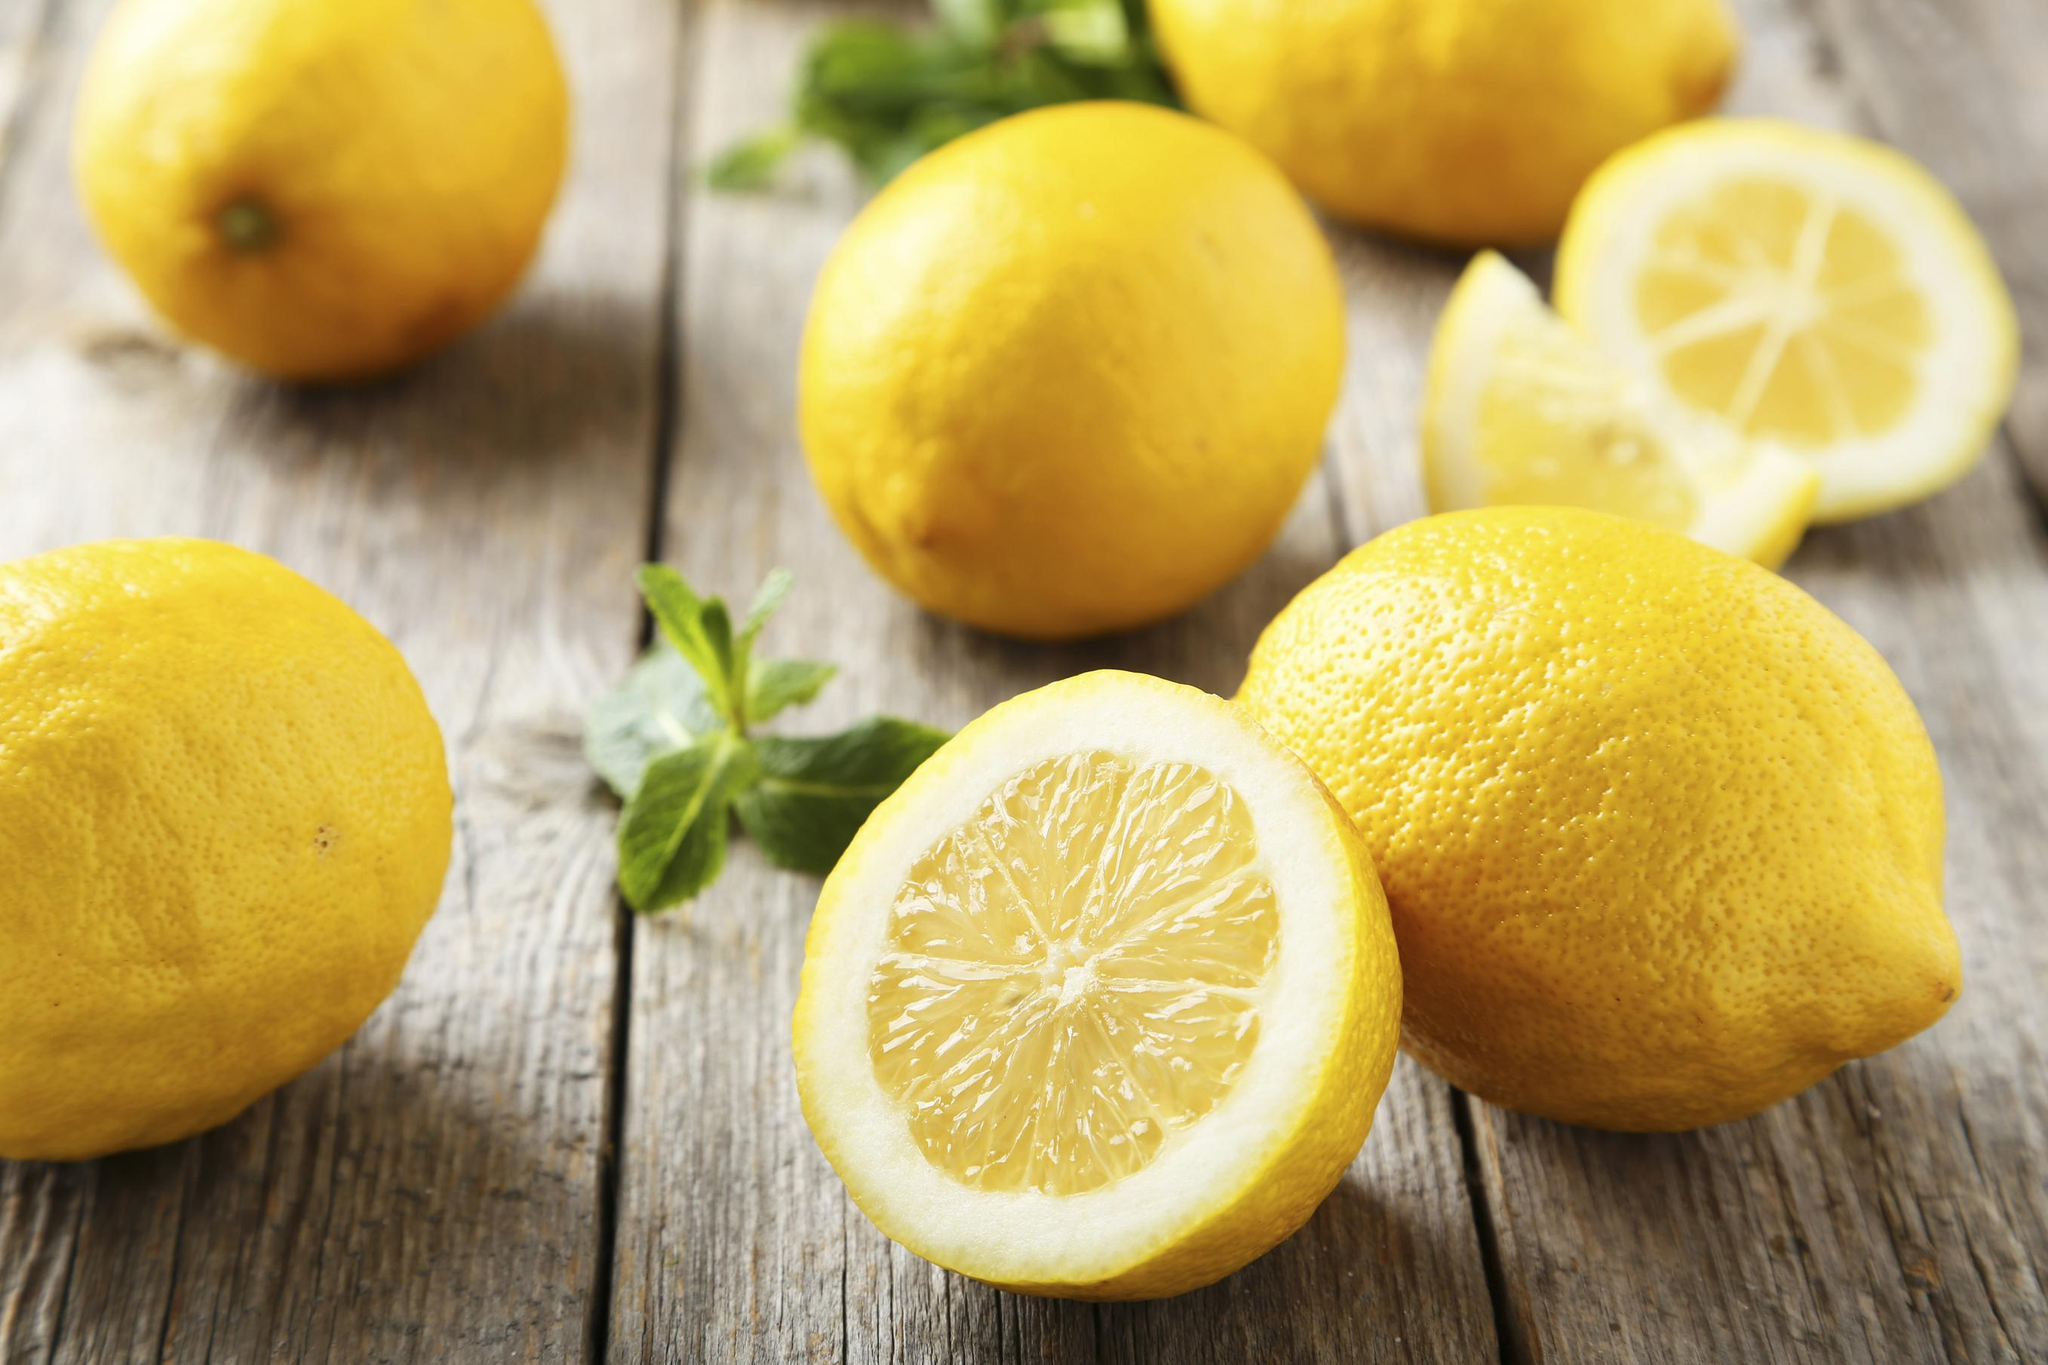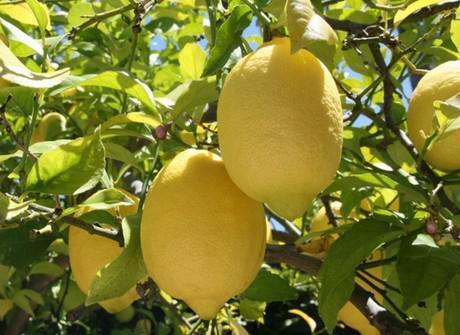The first image is the image on the left, the second image is the image on the right. Examine the images to the left and right. Is the description "A single half of a lemon sits with some whole lemons in each of the images." accurate? Answer yes or no. No. The first image is the image on the left, the second image is the image on the right. For the images displayed, is the sentence "The lemons are still hanging from the tree in one picture." factually correct? Answer yes or no. Yes. 